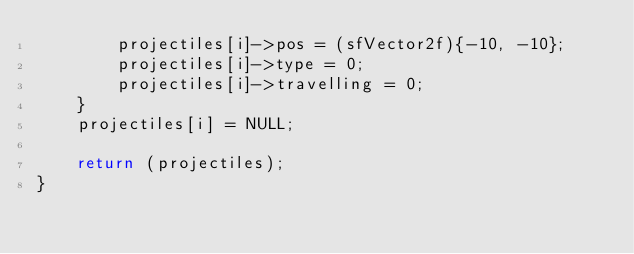<code> <loc_0><loc_0><loc_500><loc_500><_C_>        projectiles[i]->pos = (sfVector2f){-10, -10};
        projectiles[i]->type = 0;
        projectiles[i]->travelling = 0;
    }
    projectiles[i] = NULL;

    return (projectiles);
}

</code> 